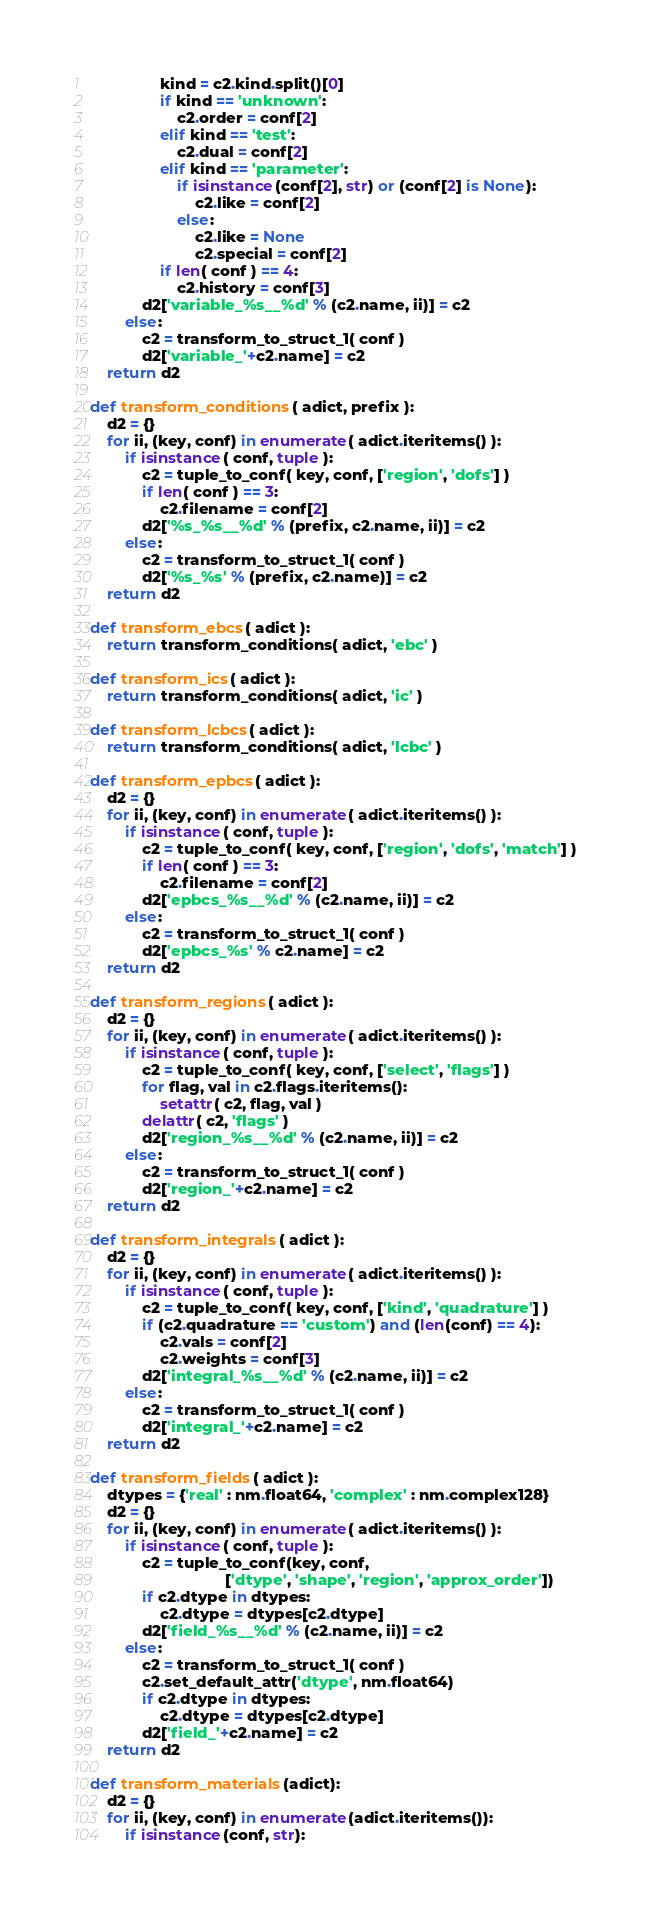Convert code to text. <code><loc_0><loc_0><loc_500><loc_500><_Python_>                kind = c2.kind.split()[0]
                if kind == 'unknown':
                    c2.order = conf[2]
                elif kind == 'test':
                    c2.dual = conf[2]
                elif kind == 'parameter':
                    if isinstance(conf[2], str) or (conf[2] is None):
                        c2.like = conf[2]
                    else:
                        c2.like = None
                        c2.special = conf[2]
                if len( conf ) == 4:
                    c2.history = conf[3]
            d2['variable_%s__%d' % (c2.name, ii)] = c2
        else:
            c2 = transform_to_struct_1( conf )
            d2['variable_'+c2.name] = c2
    return d2

def transform_conditions( adict, prefix ):
    d2 = {}
    for ii, (key, conf) in enumerate( adict.iteritems() ):
        if isinstance( conf, tuple ):
            c2 = tuple_to_conf( key, conf, ['region', 'dofs'] )
            if len( conf ) == 3:
                c2.filename = conf[2]
            d2['%s_%s__%d' % (prefix, c2.name, ii)] = c2
        else:
            c2 = transform_to_struct_1( conf )
            d2['%s_%s' % (prefix, c2.name)] = c2
    return d2
    
def transform_ebcs( adict ):
    return transform_conditions( adict, 'ebc' )

def transform_ics( adict ):
    return transform_conditions( adict, 'ic' )

def transform_lcbcs( adict ):
    return transform_conditions( adict, 'lcbc' )

def transform_epbcs( adict ):
    d2 = {}
    for ii, (key, conf) in enumerate( adict.iteritems() ):
        if isinstance( conf, tuple ):
            c2 = tuple_to_conf( key, conf, ['region', 'dofs', 'match'] )
            if len( conf ) == 3:
                c2.filename = conf[2]
            d2['epbcs_%s__%d' % (c2.name, ii)] = c2
        else:
            c2 = transform_to_struct_1( conf )
            d2['epbcs_%s' % c2.name] = c2
    return d2

def transform_regions( adict ):
    d2 = {}
    for ii, (key, conf) in enumerate( adict.iteritems() ):
        if isinstance( conf, tuple ):
            c2 = tuple_to_conf( key, conf, ['select', 'flags'] )
            for flag, val in c2.flags.iteritems():
                setattr( c2, flag, val )
            delattr( c2, 'flags' )
            d2['region_%s__%d' % (c2.name, ii)] = c2
        else:
            c2 = transform_to_struct_1( conf )
            d2['region_'+c2.name] = c2
    return d2

def transform_integrals( adict ):
    d2 = {}
    for ii, (key, conf) in enumerate( adict.iteritems() ):
        if isinstance( conf, tuple ):
            c2 = tuple_to_conf( key, conf, ['kind', 'quadrature'] )
            if (c2.quadrature == 'custom') and (len(conf) == 4):
                c2.vals = conf[2]
                c2.weights = conf[3]
            d2['integral_%s__%d' % (c2.name, ii)] = c2
        else:
            c2 = transform_to_struct_1( conf )
            d2['integral_'+c2.name] = c2
    return d2

def transform_fields( adict ):
    dtypes = {'real' : nm.float64, 'complex' : nm.complex128}
    d2 = {}
    for ii, (key, conf) in enumerate( adict.iteritems() ):
        if isinstance( conf, tuple ):
            c2 = tuple_to_conf(key, conf,
                               ['dtype', 'shape', 'region', 'approx_order'])
            if c2.dtype in dtypes:
                c2.dtype = dtypes[c2.dtype]
            d2['field_%s__%d' % (c2.name, ii)] = c2
        else:
            c2 = transform_to_struct_1( conf )
            c2.set_default_attr('dtype', nm.float64)
            if c2.dtype in dtypes:
                c2.dtype = dtypes[c2.dtype]
            d2['field_'+c2.name] = c2
    return d2

def transform_materials(adict):
    d2 = {}
    for ii, (key, conf) in enumerate(adict.iteritems()):
        if isinstance(conf, str):</code> 